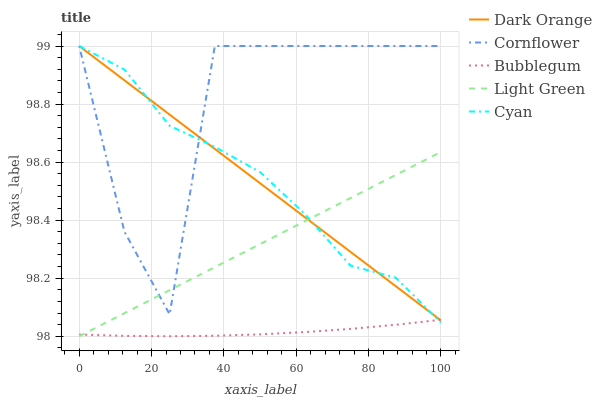Does Bubblegum have the minimum area under the curve?
Answer yes or no. Yes. Does Cornflower have the maximum area under the curve?
Answer yes or no. Yes. Does Cyan have the minimum area under the curve?
Answer yes or no. No. Does Cyan have the maximum area under the curve?
Answer yes or no. No. Is Light Green the smoothest?
Answer yes or no. Yes. Is Cornflower the roughest?
Answer yes or no. Yes. Is Cyan the smoothest?
Answer yes or no. No. Is Cyan the roughest?
Answer yes or no. No. Does Light Green have the lowest value?
Answer yes or no. Yes. Does Cyan have the lowest value?
Answer yes or no. No. Does Cornflower have the highest value?
Answer yes or no. Yes. Does Light Green have the highest value?
Answer yes or no. No. Is Bubblegum less than Cornflower?
Answer yes or no. Yes. Is Cornflower greater than Bubblegum?
Answer yes or no. Yes. Does Bubblegum intersect Light Green?
Answer yes or no. Yes. Is Bubblegum less than Light Green?
Answer yes or no. No. Is Bubblegum greater than Light Green?
Answer yes or no. No. Does Bubblegum intersect Cornflower?
Answer yes or no. No. 